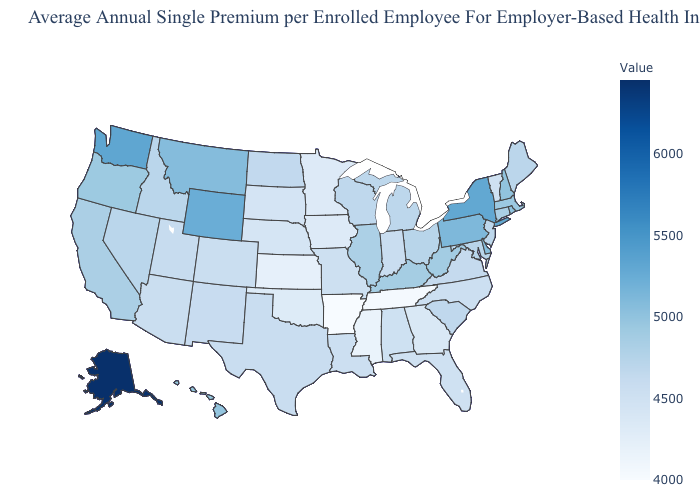Does Alaska have the highest value in the USA?
Be succinct. Yes. Does Hawaii have a lower value than New York?
Answer briefly. Yes. Which states have the lowest value in the USA?
Answer briefly. Arkansas. Does Arkansas have the lowest value in the USA?
Short answer required. Yes. 